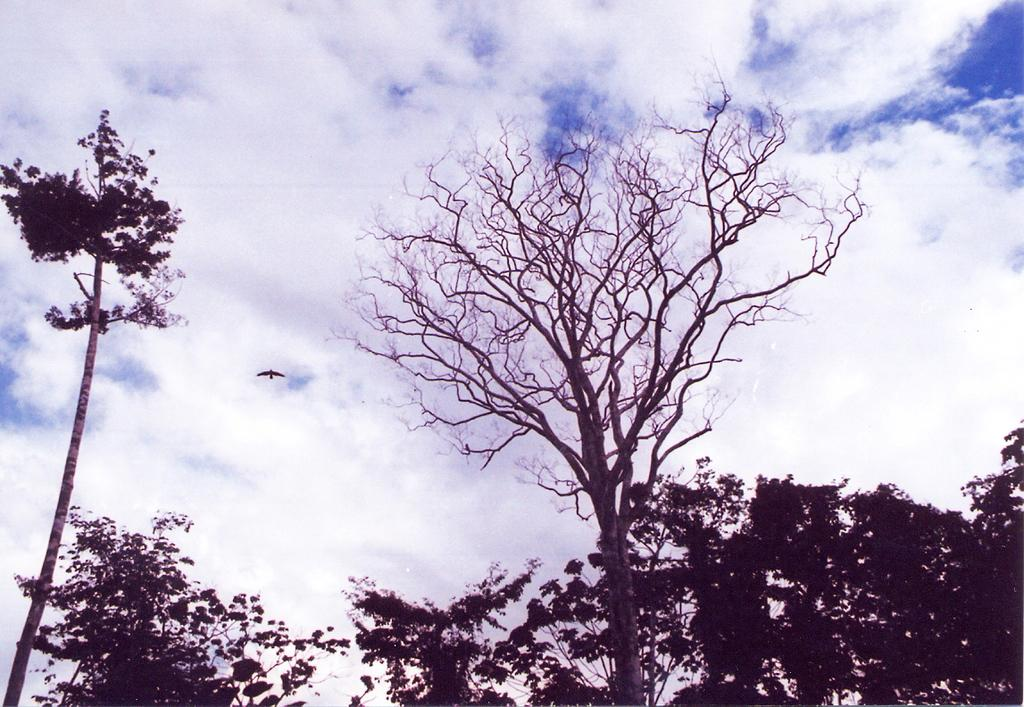What type of vegetation can be seen in the image? There are trees in the image. What is the bird in the image doing? The bird is flying in the image. What is the condition of the sky in the background? The sky in the background is cloudy. What is the weight of the love that the bird is carrying in the image? There is no indication of love or any weight being carried by the bird in the image. 